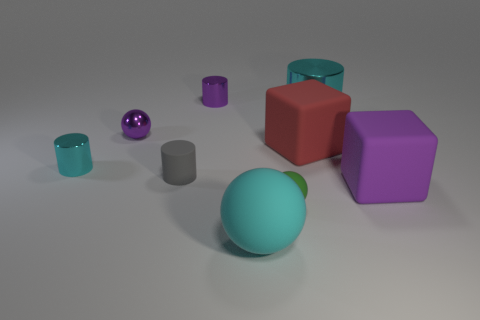Subtract 1 cylinders. How many cylinders are left? 3 Subtract all green cylinders. Subtract all cyan spheres. How many cylinders are left? 4 Add 1 yellow metal cylinders. How many objects exist? 10 Subtract all cylinders. How many objects are left? 5 Add 5 cyan cylinders. How many cyan cylinders are left? 7 Add 3 cyan objects. How many cyan objects exist? 6 Subtract 1 purple blocks. How many objects are left? 8 Subtract all tiny spheres. Subtract all tiny cylinders. How many objects are left? 4 